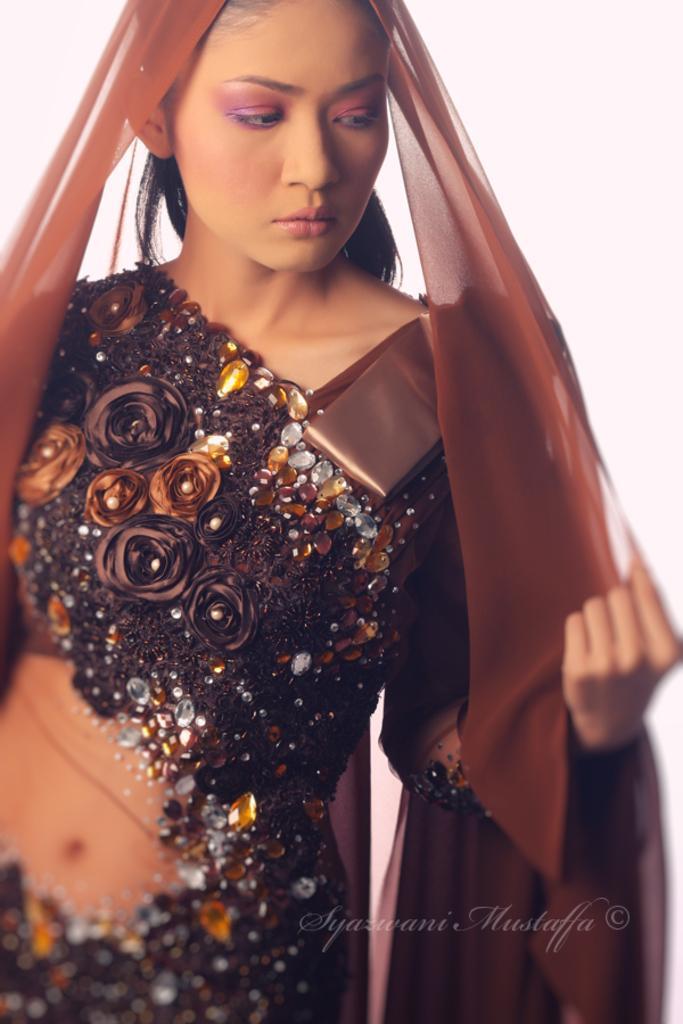Describe this image in one or two sentences. In this picture we can see a woman. 